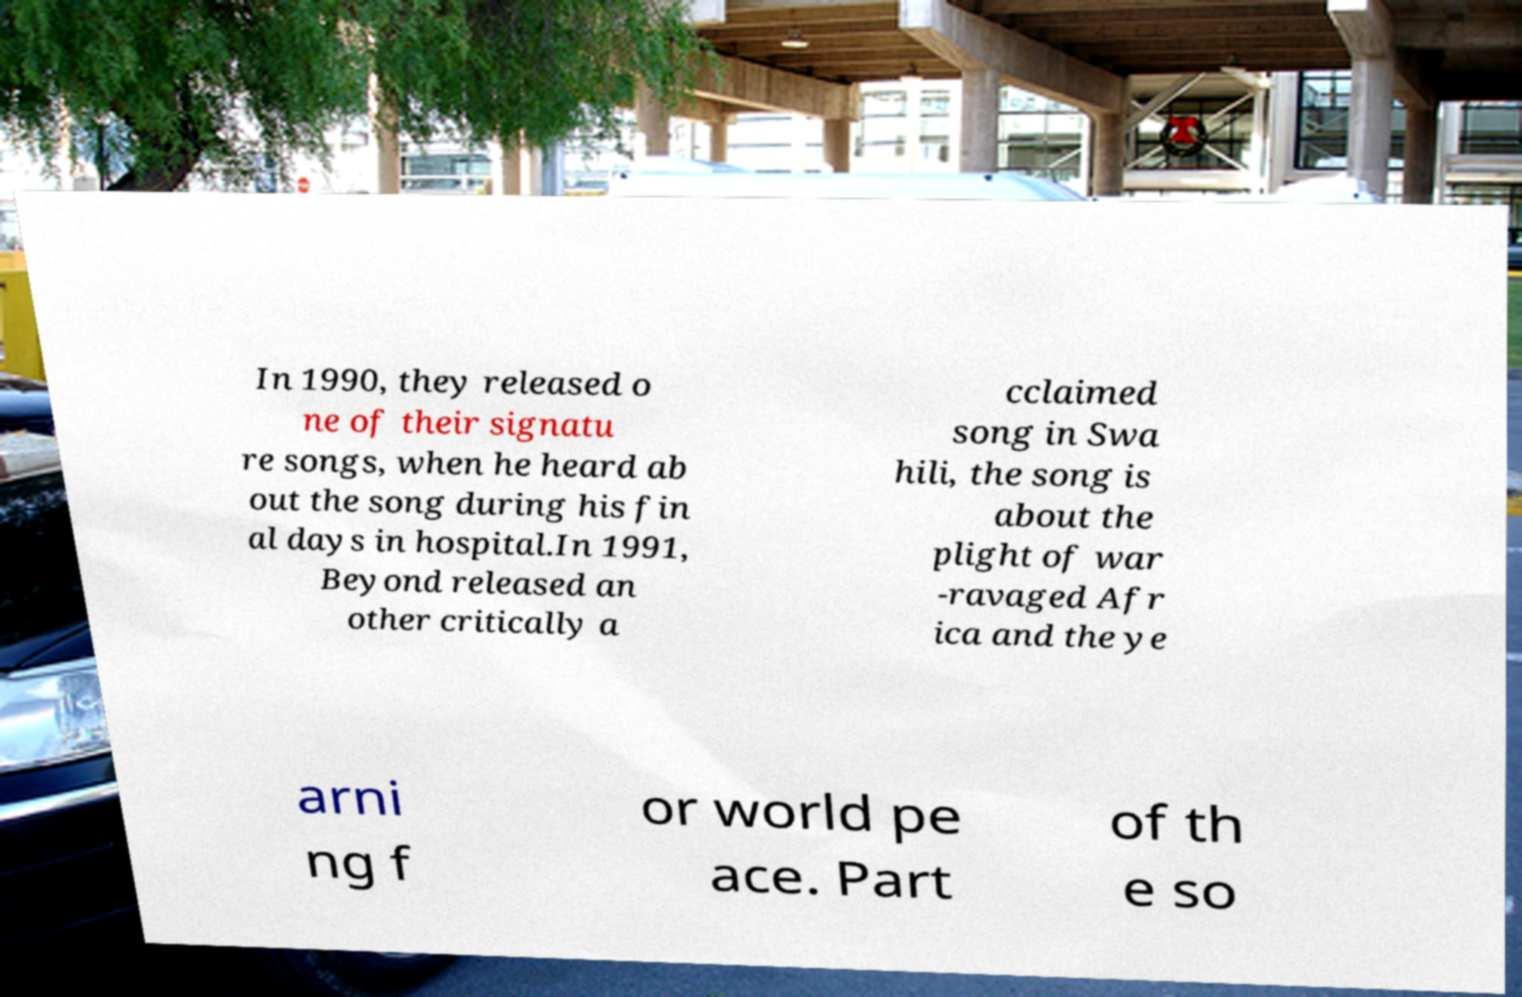Please read and relay the text visible in this image. What does it say? In 1990, they released o ne of their signatu re songs, when he heard ab out the song during his fin al days in hospital.In 1991, Beyond released an other critically a cclaimed song in Swa hili, the song is about the plight of war -ravaged Afr ica and the ye arni ng f or world pe ace. Part of th e so 